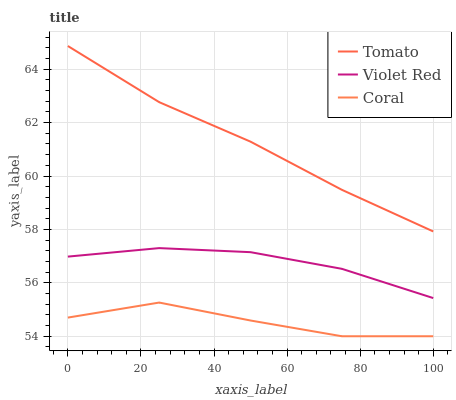Does Coral have the minimum area under the curve?
Answer yes or no. Yes. Does Tomato have the maximum area under the curve?
Answer yes or no. Yes. Does Violet Red have the minimum area under the curve?
Answer yes or no. No. Does Violet Red have the maximum area under the curve?
Answer yes or no. No. Is Tomato the smoothest?
Answer yes or no. Yes. Is Coral the roughest?
Answer yes or no. Yes. Is Violet Red the smoothest?
Answer yes or no. No. Is Violet Red the roughest?
Answer yes or no. No. Does Coral have the lowest value?
Answer yes or no. Yes. Does Violet Red have the lowest value?
Answer yes or no. No. Does Tomato have the highest value?
Answer yes or no. Yes. Does Violet Red have the highest value?
Answer yes or no. No. Is Coral less than Violet Red?
Answer yes or no. Yes. Is Tomato greater than Coral?
Answer yes or no. Yes. Does Coral intersect Violet Red?
Answer yes or no. No. 